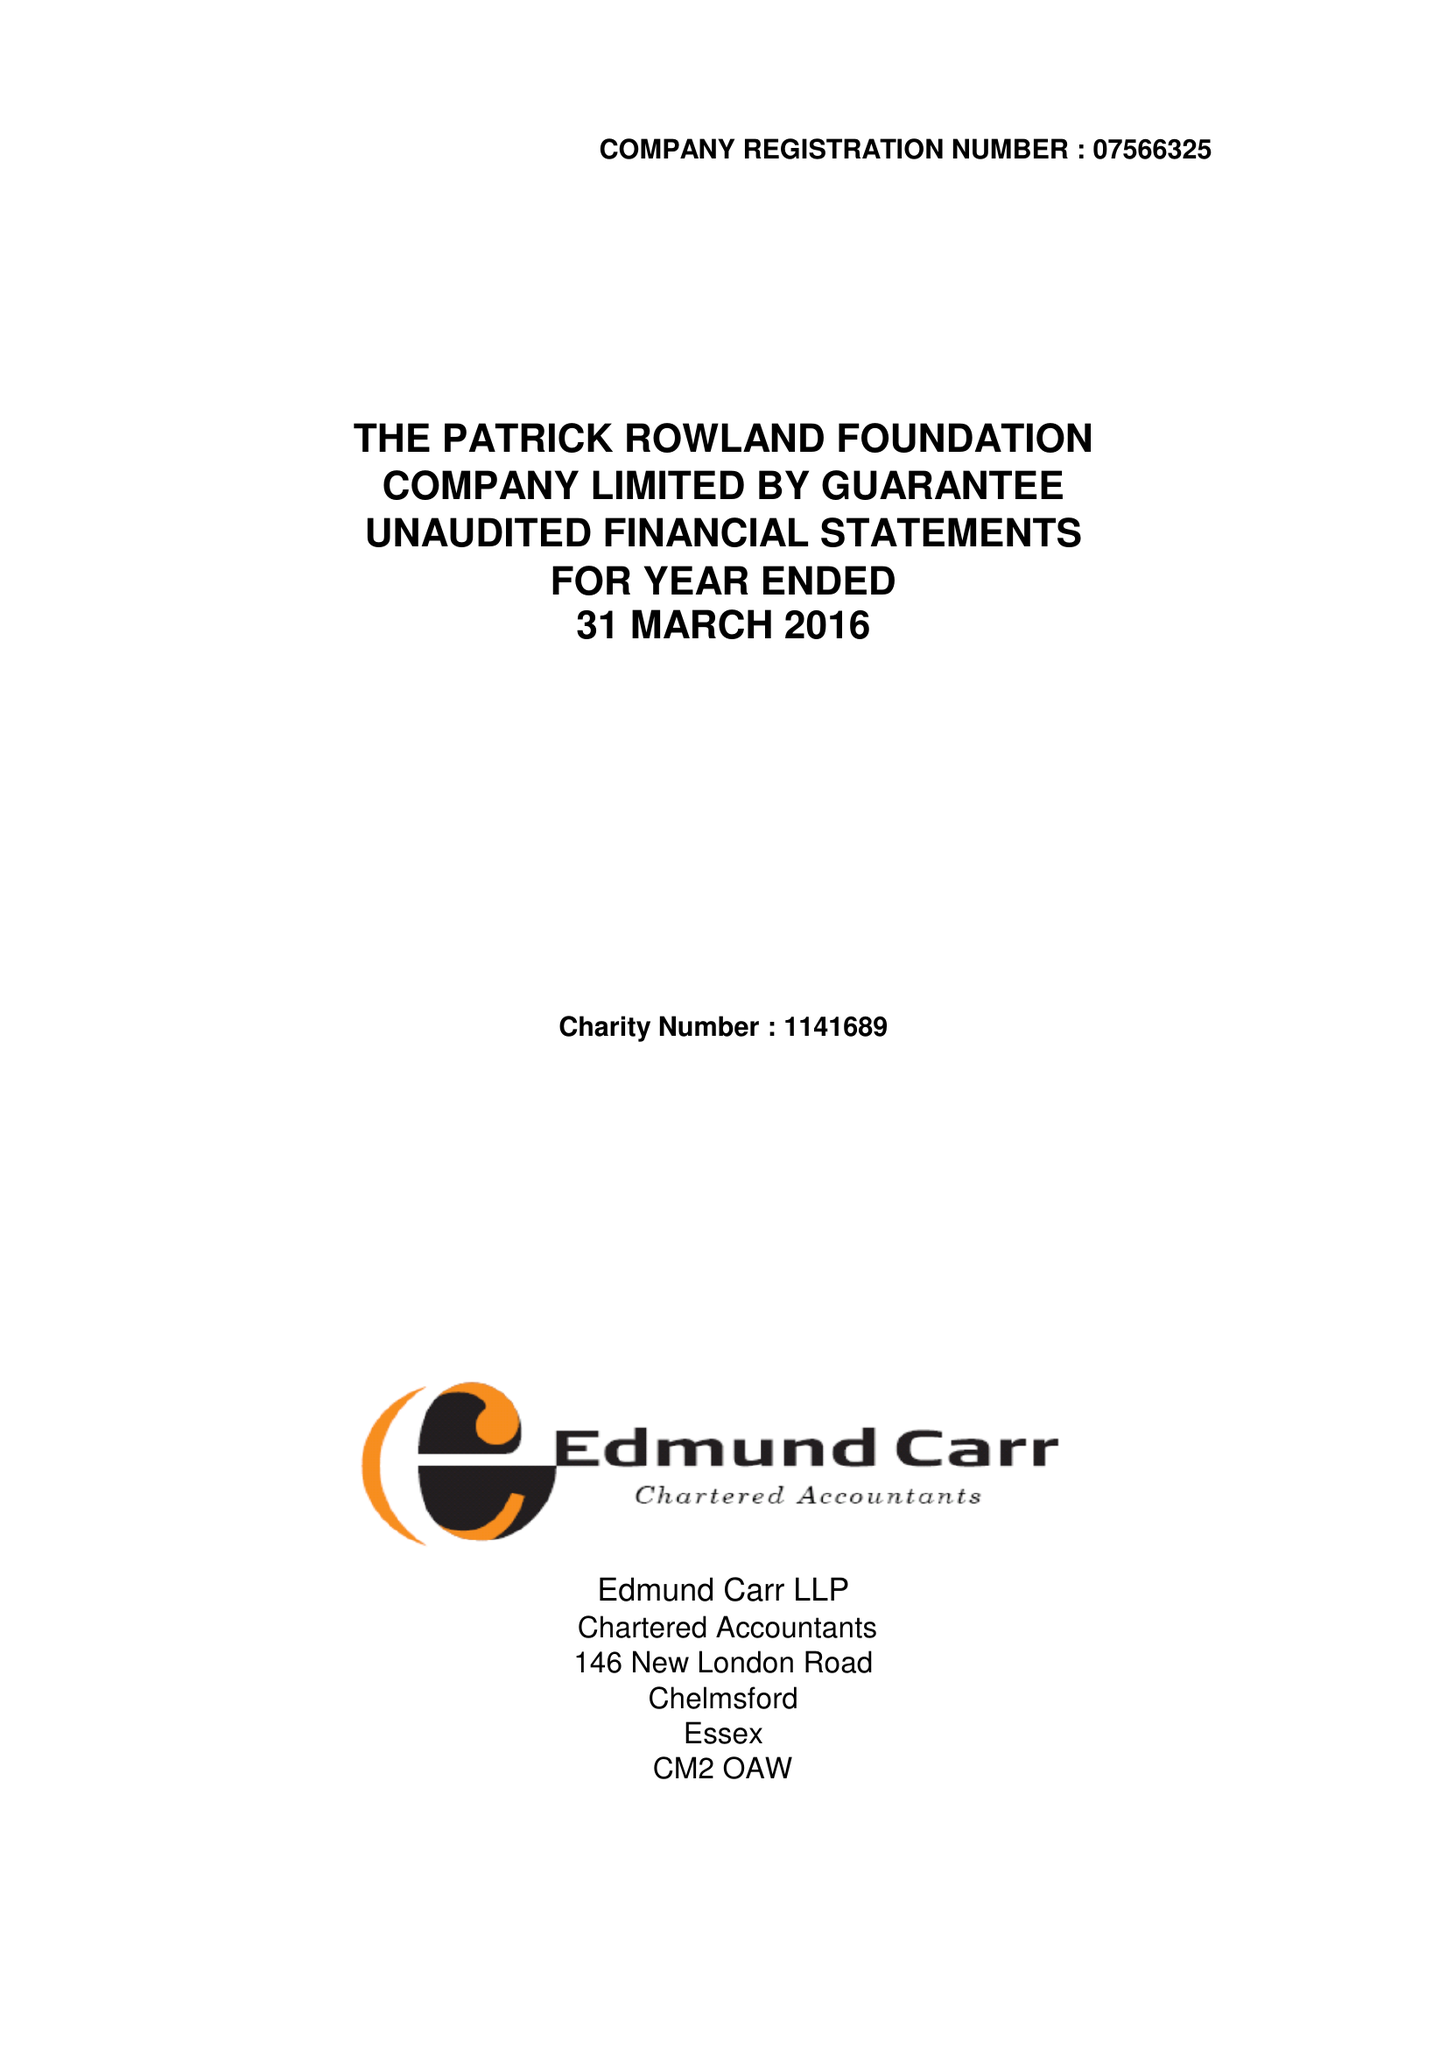What is the value for the charity_name?
Answer the question using a single word or phrase. The Patrick Rowland Foundation 